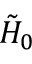<formula> <loc_0><loc_0><loc_500><loc_500>\tilde { H } _ { 0 }</formula> 